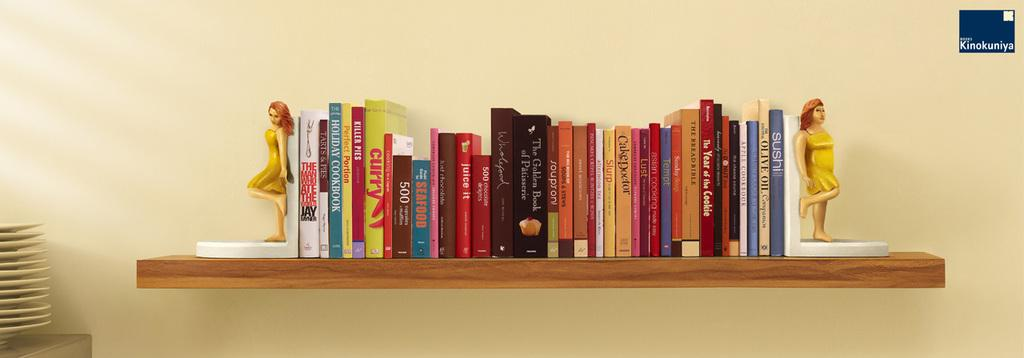<image>
Render a clear and concise summary of the photo. Book on a shelf with "The Man Who Ate the World" is on the left. 